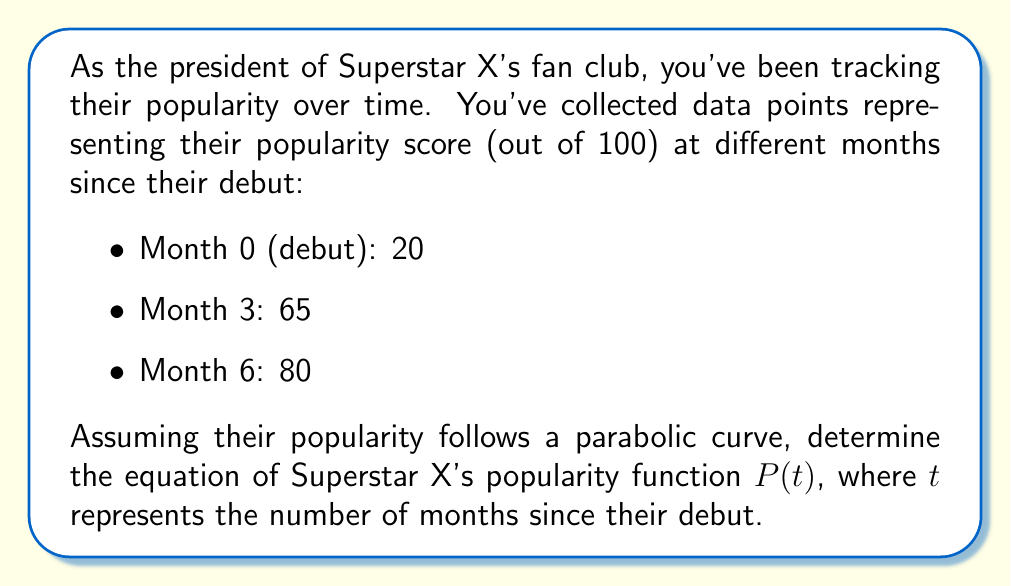Can you answer this question? Let's approach this step-by-step:

1) The general form of a quadratic function is $P(t) = at^2 + bt + c$, where $a$, $b$, and $c$ are constants we need to determine.

2) We have three points that satisfy this equation:
   $(0, 20)$, $(3, 65)$, and $(6, 80)$

3) Let's substitute these points into the general equation:
   $20 = a(0)^2 + b(0) + c$
   $65 = a(3)^2 + b(3) + c$
   $80 = a(6)^2 + b(6) + c$

4) From the first equation, we can deduce that $c = 20$.

5) Now we have two equations with two unknowns:
   $65 = 9a + 3b + 20$
   $80 = 36a + 6b + 20$

6) Simplify:
   $45 = 9a + 3b$
   $60 = 36a + 6b$

7) Multiply the first equation by 4 and the second by -1:
   $180 = 36a + 12b$
   $-60 = -36a - 6b$

8) Add these equations:
   $120 = 6b$
   $b = 20$

9) Substitute this back into one of the simplified equations:
   $45 = 9a + 3(20)$
   $45 = 9a + 60$
   $-15 = 9a$
   $a = -\frac{5}{3}$

10) Therefore, the equation of the popularity function is:
    $P(t) = -\frac{5}{3}t^2 + 20t + 20$
Answer: $P(t) = -\frac{5}{3}t^2 + 20t + 20$ 